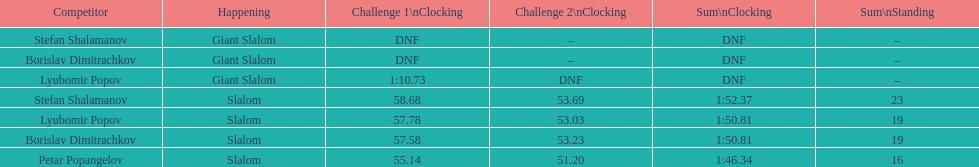What is the difference in time for petar popangelov in race 1and 2 3.94. 